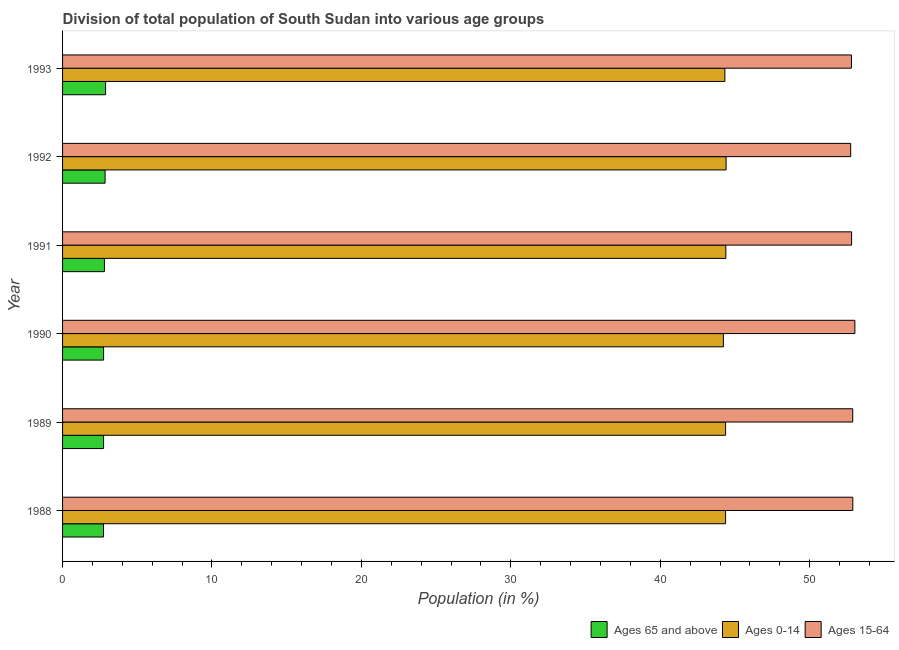Are the number of bars per tick equal to the number of legend labels?
Ensure brevity in your answer.  Yes. Are the number of bars on each tick of the Y-axis equal?
Your response must be concise. Yes. How many bars are there on the 5th tick from the top?
Make the answer very short. 3. How many bars are there on the 2nd tick from the bottom?
Offer a terse response. 3. What is the label of the 1st group of bars from the top?
Make the answer very short. 1993. What is the percentage of population within the age-group 15-64 in 1991?
Offer a terse response. 52.81. Across all years, what is the maximum percentage of population within the age-group 15-64?
Your answer should be very brief. 53.03. Across all years, what is the minimum percentage of population within the age-group of 65 and above?
Your answer should be very brief. 2.74. In which year was the percentage of population within the age-group 15-64 maximum?
Give a very brief answer. 1990. What is the total percentage of population within the age-group 15-64 in the graph?
Make the answer very short. 317.15. What is the difference between the percentage of population within the age-group 0-14 in 1989 and that in 1993?
Keep it short and to the point. 0.05. What is the difference between the percentage of population within the age-group 15-64 in 1991 and the percentage of population within the age-group of 65 and above in 1993?
Offer a terse response. 49.93. What is the average percentage of population within the age-group 0-14 per year?
Your answer should be compact. 44.35. In the year 1992, what is the difference between the percentage of population within the age-group of 65 and above and percentage of population within the age-group 0-14?
Offer a very short reply. -41.56. What is the ratio of the percentage of population within the age-group 15-64 in 1990 to that in 1991?
Provide a short and direct response. 1. Is the difference between the percentage of population within the age-group 0-14 in 1988 and 1992 greater than the difference between the percentage of population within the age-group of 65 and above in 1988 and 1992?
Offer a terse response. Yes. What is the difference between the highest and the second highest percentage of population within the age-group 15-64?
Your response must be concise. 0.14. What is the difference between the highest and the lowest percentage of population within the age-group 0-14?
Offer a very short reply. 0.18. What does the 2nd bar from the top in 1992 represents?
Offer a terse response. Ages 0-14. What does the 3rd bar from the bottom in 1992 represents?
Your answer should be very brief. Ages 15-64. Is it the case that in every year, the sum of the percentage of population within the age-group of 65 and above and percentage of population within the age-group 0-14 is greater than the percentage of population within the age-group 15-64?
Your answer should be compact. No. Are all the bars in the graph horizontal?
Your answer should be very brief. Yes. How many years are there in the graph?
Offer a terse response. 6. What is the difference between two consecutive major ticks on the X-axis?
Make the answer very short. 10. Are the values on the major ticks of X-axis written in scientific E-notation?
Offer a very short reply. No. Does the graph contain grids?
Provide a short and direct response. No. What is the title of the graph?
Your response must be concise. Division of total population of South Sudan into various age groups
. What is the label or title of the X-axis?
Provide a succinct answer. Population (in %). What is the label or title of the Y-axis?
Provide a succinct answer. Year. What is the Population (in %) in Ages 65 and above in 1988?
Give a very brief answer. 2.74. What is the Population (in %) in Ages 0-14 in 1988?
Ensure brevity in your answer.  44.37. What is the Population (in %) of Ages 15-64 in 1988?
Ensure brevity in your answer.  52.89. What is the Population (in %) of Ages 65 and above in 1989?
Your answer should be compact. 2.74. What is the Population (in %) in Ages 0-14 in 1989?
Give a very brief answer. 44.37. What is the Population (in %) in Ages 15-64 in 1989?
Your answer should be very brief. 52.88. What is the Population (in %) in Ages 65 and above in 1990?
Make the answer very short. 2.75. What is the Population (in %) in Ages 0-14 in 1990?
Your response must be concise. 44.23. What is the Population (in %) of Ages 15-64 in 1990?
Offer a terse response. 53.03. What is the Population (in %) of Ages 65 and above in 1991?
Your response must be concise. 2.8. What is the Population (in %) in Ages 0-14 in 1991?
Keep it short and to the point. 44.39. What is the Population (in %) of Ages 15-64 in 1991?
Offer a terse response. 52.81. What is the Population (in %) of Ages 65 and above in 1992?
Provide a succinct answer. 2.85. What is the Population (in %) in Ages 0-14 in 1992?
Provide a succinct answer. 44.41. What is the Population (in %) of Ages 15-64 in 1992?
Keep it short and to the point. 52.75. What is the Population (in %) of Ages 65 and above in 1993?
Make the answer very short. 2.88. What is the Population (in %) of Ages 0-14 in 1993?
Your answer should be compact. 44.33. What is the Population (in %) in Ages 15-64 in 1993?
Your answer should be compact. 52.8. Across all years, what is the maximum Population (in %) in Ages 65 and above?
Provide a short and direct response. 2.88. Across all years, what is the maximum Population (in %) of Ages 0-14?
Offer a terse response. 44.41. Across all years, what is the maximum Population (in %) of Ages 15-64?
Offer a very short reply. 53.03. Across all years, what is the minimum Population (in %) in Ages 65 and above?
Keep it short and to the point. 2.74. Across all years, what is the minimum Population (in %) of Ages 0-14?
Give a very brief answer. 44.23. Across all years, what is the minimum Population (in %) of Ages 15-64?
Your answer should be very brief. 52.75. What is the total Population (in %) of Ages 65 and above in the graph?
Your answer should be compact. 16.76. What is the total Population (in %) of Ages 0-14 in the graph?
Ensure brevity in your answer.  266.1. What is the total Population (in %) in Ages 15-64 in the graph?
Make the answer very short. 317.15. What is the difference between the Population (in %) in Ages 65 and above in 1988 and that in 1989?
Offer a terse response. -0.01. What is the difference between the Population (in %) in Ages 0-14 in 1988 and that in 1989?
Give a very brief answer. 0. What is the difference between the Population (in %) of Ages 15-64 in 1988 and that in 1989?
Your answer should be very brief. 0. What is the difference between the Population (in %) in Ages 65 and above in 1988 and that in 1990?
Provide a succinct answer. -0.01. What is the difference between the Population (in %) in Ages 0-14 in 1988 and that in 1990?
Your response must be concise. 0.15. What is the difference between the Population (in %) of Ages 15-64 in 1988 and that in 1990?
Ensure brevity in your answer.  -0.14. What is the difference between the Population (in %) in Ages 65 and above in 1988 and that in 1991?
Make the answer very short. -0.06. What is the difference between the Population (in %) of Ages 0-14 in 1988 and that in 1991?
Your response must be concise. -0.02. What is the difference between the Population (in %) of Ages 15-64 in 1988 and that in 1991?
Make the answer very short. 0.08. What is the difference between the Population (in %) in Ages 65 and above in 1988 and that in 1992?
Keep it short and to the point. -0.11. What is the difference between the Population (in %) in Ages 0-14 in 1988 and that in 1992?
Your answer should be very brief. -0.03. What is the difference between the Population (in %) of Ages 15-64 in 1988 and that in 1992?
Your answer should be very brief. 0.14. What is the difference between the Population (in %) in Ages 65 and above in 1988 and that in 1993?
Make the answer very short. -0.14. What is the difference between the Population (in %) of Ages 0-14 in 1988 and that in 1993?
Keep it short and to the point. 0.05. What is the difference between the Population (in %) in Ages 15-64 in 1988 and that in 1993?
Provide a short and direct response. 0.09. What is the difference between the Population (in %) of Ages 65 and above in 1989 and that in 1990?
Offer a very short reply. -0. What is the difference between the Population (in %) of Ages 0-14 in 1989 and that in 1990?
Ensure brevity in your answer.  0.14. What is the difference between the Population (in %) of Ages 15-64 in 1989 and that in 1990?
Offer a terse response. -0.14. What is the difference between the Population (in %) in Ages 65 and above in 1989 and that in 1991?
Ensure brevity in your answer.  -0.06. What is the difference between the Population (in %) of Ages 0-14 in 1989 and that in 1991?
Offer a very short reply. -0.02. What is the difference between the Population (in %) in Ages 15-64 in 1989 and that in 1991?
Your answer should be compact. 0.07. What is the difference between the Population (in %) in Ages 65 and above in 1989 and that in 1992?
Your response must be concise. -0.1. What is the difference between the Population (in %) of Ages 0-14 in 1989 and that in 1992?
Provide a short and direct response. -0.03. What is the difference between the Population (in %) of Ages 15-64 in 1989 and that in 1992?
Ensure brevity in your answer.  0.14. What is the difference between the Population (in %) in Ages 65 and above in 1989 and that in 1993?
Your answer should be compact. -0.13. What is the difference between the Population (in %) of Ages 0-14 in 1989 and that in 1993?
Provide a succinct answer. 0.05. What is the difference between the Population (in %) of Ages 15-64 in 1989 and that in 1993?
Your response must be concise. 0.09. What is the difference between the Population (in %) in Ages 65 and above in 1990 and that in 1991?
Your answer should be compact. -0.06. What is the difference between the Population (in %) in Ages 0-14 in 1990 and that in 1991?
Your answer should be compact. -0.16. What is the difference between the Population (in %) of Ages 15-64 in 1990 and that in 1991?
Offer a very short reply. 0.22. What is the difference between the Population (in %) of Ages 65 and above in 1990 and that in 1992?
Provide a short and direct response. -0.1. What is the difference between the Population (in %) of Ages 0-14 in 1990 and that in 1992?
Offer a terse response. -0.18. What is the difference between the Population (in %) in Ages 15-64 in 1990 and that in 1992?
Make the answer very short. 0.28. What is the difference between the Population (in %) in Ages 65 and above in 1990 and that in 1993?
Give a very brief answer. -0.13. What is the difference between the Population (in %) of Ages 0-14 in 1990 and that in 1993?
Make the answer very short. -0.1. What is the difference between the Population (in %) of Ages 15-64 in 1990 and that in 1993?
Offer a terse response. 0.23. What is the difference between the Population (in %) of Ages 65 and above in 1991 and that in 1992?
Offer a very short reply. -0.05. What is the difference between the Population (in %) of Ages 0-14 in 1991 and that in 1992?
Give a very brief answer. -0.02. What is the difference between the Population (in %) of Ages 15-64 in 1991 and that in 1992?
Offer a terse response. 0.06. What is the difference between the Population (in %) in Ages 65 and above in 1991 and that in 1993?
Give a very brief answer. -0.08. What is the difference between the Population (in %) in Ages 0-14 in 1991 and that in 1993?
Provide a succinct answer. 0.07. What is the difference between the Population (in %) in Ages 15-64 in 1991 and that in 1993?
Provide a succinct answer. 0.01. What is the difference between the Population (in %) of Ages 65 and above in 1992 and that in 1993?
Make the answer very short. -0.03. What is the difference between the Population (in %) in Ages 0-14 in 1992 and that in 1993?
Ensure brevity in your answer.  0.08. What is the difference between the Population (in %) of Ages 15-64 in 1992 and that in 1993?
Give a very brief answer. -0.05. What is the difference between the Population (in %) of Ages 65 and above in 1988 and the Population (in %) of Ages 0-14 in 1989?
Your answer should be very brief. -41.63. What is the difference between the Population (in %) in Ages 65 and above in 1988 and the Population (in %) in Ages 15-64 in 1989?
Ensure brevity in your answer.  -50.14. What is the difference between the Population (in %) in Ages 0-14 in 1988 and the Population (in %) in Ages 15-64 in 1989?
Provide a succinct answer. -8.51. What is the difference between the Population (in %) in Ages 65 and above in 1988 and the Population (in %) in Ages 0-14 in 1990?
Your answer should be very brief. -41.49. What is the difference between the Population (in %) of Ages 65 and above in 1988 and the Population (in %) of Ages 15-64 in 1990?
Provide a short and direct response. -50.29. What is the difference between the Population (in %) of Ages 0-14 in 1988 and the Population (in %) of Ages 15-64 in 1990?
Provide a short and direct response. -8.65. What is the difference between the Population (in %) of Ages 65 and above in 1988 and the Population (in %) of Ages 0-14 in 1991?
Your response must be concise. -41.65. What is the difference between the Population (in %) in Ages 65 and above in 1988 and the Population (in %) in Ages 15-64 in 1991?
Your answer should be very brief. -50.07. What is the difference between the Population (in %) of Ages 0-14 in 1988 and the Population (in %) of Ages 15-64 in 1991?
Offer a very short reply. -8.43. What is the difference between the Population (in %) in Ages 65 and above in 1988 and the Population (in %) in Ages 0-14 in 1992?
Your answer should be very brief. -41.67. What is the difference between the Population (in %) in Ages 65 and above in 1988 and the Population (in %) in Ages 15-64 in 1992?
Your response must be concise. -50.01. What is the difference between the Population (in %) of Ages 0-14 in 1988 and the Population (in %) of Ages 15-64 in 1992?
Your answer should be very brief. -8.37. What is the difference between the Population (in %) in Ages 65 and above in 1988 and the Population (in %) in Ages 0-14 in 1993?
Offer a terse response. -41.59. What is the difference between the Population (in %) of Ages 65 and above in 1988 and the Population (in %) of Ages 15-64 in 1993?
Ensure brevity in your answer.  -50.06. What is the difference between the Population (in %) in Ages 0-14 in 1988 and the Population (in %) in Ages 15-64 in 1993?
Provide a succinct answer. -8.42. What is the difference between the Population (in %) in Ages 65 and above in 1989 and the Population (in %) in Ages 0-14 in 1990?
Keep it short and to the point. -41.48. What is the difference between the Population (in %) in Ages 65 and above in 1989 and the Population (in %) in Ages 15-64 in 1990?
Make the answer very short. -50.28. What is the difference between the Population (in %) of Ages 0-14 in 1989 and the Population (in %) of Ages 15-64 in 1990?
Provide a succinct answer. -8.65. What is the difference between the Population (in %) in Ages 65 and above in 1989 and the Population (in %) in Ages 0-14 in 1991?
Provide a short and direct response. -41.65. What is the difference between the Population (in %) in Ages 65 and above in 1989 and the Population (in %) in Ages 15-64 in 1991?
Your answer should be compact. -50.06. What is the difference between the Population (in %) in Ages 0-14 in 1989 and the Population (in %) in Ages 15-64 in 1991?
Give a very brief answer. -8.43. What is the difference between the Population (in %) in Ages 65 and above in 1989 and the Population (in %) in Ages 0-14 in 1992?
Make the answer very short. -41.66. What is the difference between the Population (in %) in Ages 65 and above in 1989 and the Population (in %) in Ages 15-64 in 1992?
Your answer should be compact. -50. What is the difference between the Population (in %) in Ages 0-14 in 1989 and the Population (in %) in Ages 15-64 in 1992?
Provide a short and direct response. -8.37. What is the difference between the Population (in %) in Ages 65 and above in 1989 and the Population (in %) in Ages 0-14 in 1993?
Offer a very short reply. -41.58. What is the difference between the Population (in %) in Ages 65 and above in 1989 and the Population (in %) in Ages 15-64 in 1993?
Provide a succinct answer. -50.05. What is the difference between the Population (in %) of Ages 0-14 in 1989 and the Population (in %) of Ages 15-64 in 1993?
Provide a succinct answer. -8.42. What is the difference between the Population (in %) of Ages 65 and above in 1990 and the Population (in %) of Ages 0-14 in 1991?
Offer a very short reply. -41.65. What is the difference between the Population (in %) in Ages 65 and above in 1990 and the Population (in %) in Ages 15-64 in 1991?
Your answer should be compact. -50.06. What is the difference between the Population (in %) in Ages 0-14 in 1990 and the Population (in %) in Ages 15-64 in 1991?
Your answer should be very brief. -8.58. What is the difference between the Population (in %) of Ages 65 and above in 1990 and the Population (in %) of Ages 0-14 in 1992?
Offer a very short reply. -41.66. What is the difference between the Population (in %) of Ages 65 and above in 1990 and the Population (in %) of Ages 15-64 in 1992?
Provide a short and direct response. -50. What is the difference between the Population (in %) in Ages 0-14 in 1990 and the Population (in %) in Ages 15-64 in 1992?
Keep it short and to the point. -8.52. What is the difference between the Population (in %) in Ages 65 and above in 1990 and the Population (in %) in Ages 0-14 in 1993?
Make the answer very short. -41.58. What is the difference between the Population (in %) of Ages 65 and above in 1990 and the Population (in %) of Ages 15-64 in 1993?
Ensure brevity in your answer.  -50.05. What is the difference between the Population (in %) of Ages 0-14 in 1990 and the Population (in %) of Ages 15-64 in 1993?
Ensure brevity in your answer.  -8.57. What is the difference between the Population (in %) of Ages 65 and above in 1991 and the Population (in %) of Ages 0-14 in 1992?
Ensure brevity in your answer.  -41.61. What is the difference between the Population (in %) in Ages 65 and above in 1991 and the Population (in %) in Ages 15-64 in 1992?
Your response must be concise. -49.95. What is the difference between the Population (in %) in Ages 0-14 in 1991 and the Population (in %) in Ages 15-64 in 1992?
Offer a very short reply. -8.35. What is the difference between the Population (in %) in Ages 65 and above in 1991 and the Population (in %) in Ages 0-14 in 1993?
Keep it short and to the point. -41.52. What is the difference between the Population (in %) of Ages 65 and above in 1991 and the Population (in %) of Ages 15-64 in 1993?
Make the answer very short. -50. What is the difference between the Population (in %) in Ages 0-14 in 1991 and the Population (in %) in Ages 15-64 in 1993?
Give a very brief answer. -8.4. What is the difference between the Population (in %) in Ages 65 and above in 1992 and the Population (in %) in Ages 0-14 in 1993?
Offer a very short reply. -41.48. What is the difference between the Population (in %) of Ages 65 and above in 1992 and the Population (in %) of Ages 15-64 in 1993?
Give a very brief answer. -49.95. What is the difference between the Population (in %) in Ages 0-14 in 1992 and the Population (in %) in Ages 15-64 in 1993?
Give a very brief answer. -8.39. What is the average Population (in %) of Ages 65 and above per year?
Offer a terse response. 2.79. What is the average Population (in %) of Ages 0-14 per year?
Give a very brief answer. 44.35. What is the average Population (in %) in Ages 15-64 per year?
Ensure brevity in your answer.  52.86. In the year 1988, what is the difference between the Population (in %) of Ages 65 and above and Population (in %) of Ages 0-14?
Your response must be concise. -41.63. In the year 1988, what is the difference between the Population (in %) in Ages 65 and above and Population (in %) in Ages 15-64?
Keep it short and to the point. -50.15. In the year 1988, what is the difference between the Population (in %) of Ages 0-14 and Population (in %) of Ages 15-64?
Give a very brief answer. -8.51. In the year 1989, what is the difference between the Population (in %) of Ages 65 and above and Population (in %) of Ages 0-14?
Provide a short and direct response. -41.63. In the year 1989, what is the difference between the Population (in %) of Ages 65 and above and Population (in %) of Ages 15-64?
Keep it short and to the point. -50.14. In the year 1989, what is the difference between the Population (in %) in Ages 0-14 and Population (in %) in Ages 15-64?
Offer a very short reply. -8.51. In the year 1990, what is the difference between the Population (in %) in Ages 65 and above and Population (in %) in Ages 0-14?
Give a very brief answer. -41.48. In the year 1990, what is the difference between the Population (in %) of Ages 65 and above and Population (in %) of Ages 15-64?
Offer a very short reply. -50.28. In the year 1990, what is the difference between the Population (in %) of Ages 0-14 and Population (in %) of Ages 15-64?
Give a very brief answer. -8.8. In the year 1991, what is the difference between the Population (in %) in Ages 65 and above and Population (in %) in Ages 0-14?
Give a very brief answer. -41.59. In the year 1991, what is the difference between the Population (in %) of Ages 65 and above and Population (in %) of Ages 15-64?
Your answer should be compact. -50.01. In the year 1991, what is the difference between the Population (in %) in Ages 0-14 and Population (in %) in Ages 15-64?
Make the answer very short. -8.42. In the year 1992, what is the difference between the Population (in %) of Ages 65 and above and Population (in %) of Ages 0-14?
Offer a very short reply. -41.56. In the year 1992, what is the difference between the Population (in %) in Ages 65 and above and Population (in %) in Ages 15-64?
Your response must be concise. -49.9. In the year 1992, what is the difference between the Population (in %) in Ages 0-14 and Population (in %) in Ages 15-64?
Ensure brevity in your answer.  -8.34. In the year 1993, what is the difference between the Population (in %) of Ages 65 and above and Population (in %) of Ages 0-14?
Make the answer very short. -41.45. In the year 1993, what is the difference between the Population (in %) in Ages 65 and above and Population (in %) in Ages 15-64?
Your response must be concise. -49.92. In the year 1993, what is the difference between the Population (in %) of Ages 0-14 and Population (in %) of Ages 15-64?
Provide a short and direct response. -8.47. What is the ratio of the Population (in %) of Ages 65 and above in 1988 to that in 1989?
Provide a succinct answer. 1. What is the ratio of the Population (in %) in Ages 15-64 in 1988 to that in 1989?
Make the answer very short. 1. What is the ratio of the Population (in %) of Ages 65 and above in 1988 to that in 1990?
Offer a very short reply. 1. What is the ratio of the Population (in %) of Ages 0-14 in 1988 to that in 1990?
Your answer should be compact. 1. What is the ratio of the Population (in %) in Ages 65 and above in 1988 to that in 1991?
Your response must be concise. 0.98. What is the ratio of the Population (in %) of Ages 15-64 in 1988 to that in 1991?
Keep it short and to the point. 1. What is the ratio of the Population (in %) of Ages 65 and above in 1988 to that in 1992?
Offer a terse response. 0.96. What is the ratio of the Population (in %) of Ages 65 and above in 1988 to that in 1993?
Your answer should be very brief. 0.95. What is the ratio of the Population (in %) of Ages 15-64 in 1988 to that in 1993?
Offer a very short reply. 1. What is the ratio of the Population (in %) in Ages 0-14 in 1989 to that in 1990?
Offer a very short reply. 1. What is the ratio of the Population (in %) of Ages 15-64 in 1989 to that in 1990?
Make the answer very short. 1. What is the ratio of the Population (in %) of Ages 65 and above in 1989 to that in 1992?
Provide a succinct answer. 0.96. What is the ratio of the Population (in %) of Ages 0-14 in 1989 to that in 1992?
Your answer should be very brief. 1. What is the ratio of the Population (in %) in Ages 65 and above in 1989 to that in 1993?
Provide a succinct answer. 0.95. What is the ratio of the Population (in %) in Ages 0-14 in 1989 to that in 1993?
Your answer should be very brief. 1. What is the ratio of the Population (in %) of Ages 15-64 in 1989 to that in 1993?
Your answer should be very brief. 1. What is the ratio of the Population (in %) of Ages 65 and above in 1990 to that in 1991?
Offer a very short reply. 0.98. What is the ratio of the Population (in %) of Ages 0-14 in 1990 to that in 1991?
Provide a short and direct response. 1. What is the ratio of the Population (in %) of Ages 65 and above in 1990 to that in 1992?
Give a very brief answer. 0.96. What is the ratio of the Population (in %) in Ages 0-14 in 1990 to that in 1992?
Provide a short and direct response. 1. What is the ratio of the Population (in %) in Ages 65 and above in 1990 to that in 1993?
Make the answer very short. 0.95. What is the ratio of the Population (in %) in Ages 0-14 in 1990 to that in 1993?
Your answer should be compact. 1. What is the ratio of the Population (in %) of Ages 65 and above in 1991 to that in 1992?
Provide a short and direct response. 0.98. What is the ratio of the Population (in %) of Ages 0-14 in 1991 to that in 1992?
Make the answer very short. 1. What is the ratio of the Population (in %) of Ages 15-64 in 1991 to that in 1992?
Your answer should be very brief. 1. What is the ratio of the Population (in %) of Ages 65 and above in 1991 to that in 1993?
Ensure brevity in your answer.  0.97. What is the ratio of the Population (in %) in Ages 65 and above in 1992 to that in 1993?
Offer a very short reply. 0.99. What is the ratio of the Population (in %) in Ages 0-14 in 1992 to that in 1993?
Your response must be concise. 1. What is the ratio of the Population (in %) of Ages 15-64 in 1992 to that in 1993?
Offer a very short reply. 1. What is the difference between the highest and the second highest Population (in %) of Ages 65 and above?
Provide a short and direct response. 0.03. What is the difference between the highest and the second highest Population (in %) of Ages 0-14?
Make the answer very short. 0.02. What is the difference between the highest and the second highest Population (in %) of Ages 15-64?
Your answer should be compact. 0.14. What is the difference between the highest and the lowest Population (in %) of Ages 65 and above?
Provide a succinct answer. 0.14. What is the difference between the highest and the lowest Population (in %) of Ages 0-14?
Provide a succinct answer. 0.18. What is the difference between the highest and the lowest Population (in %) in Ages 15-64?
Keep it short and to the point. 0.28. 